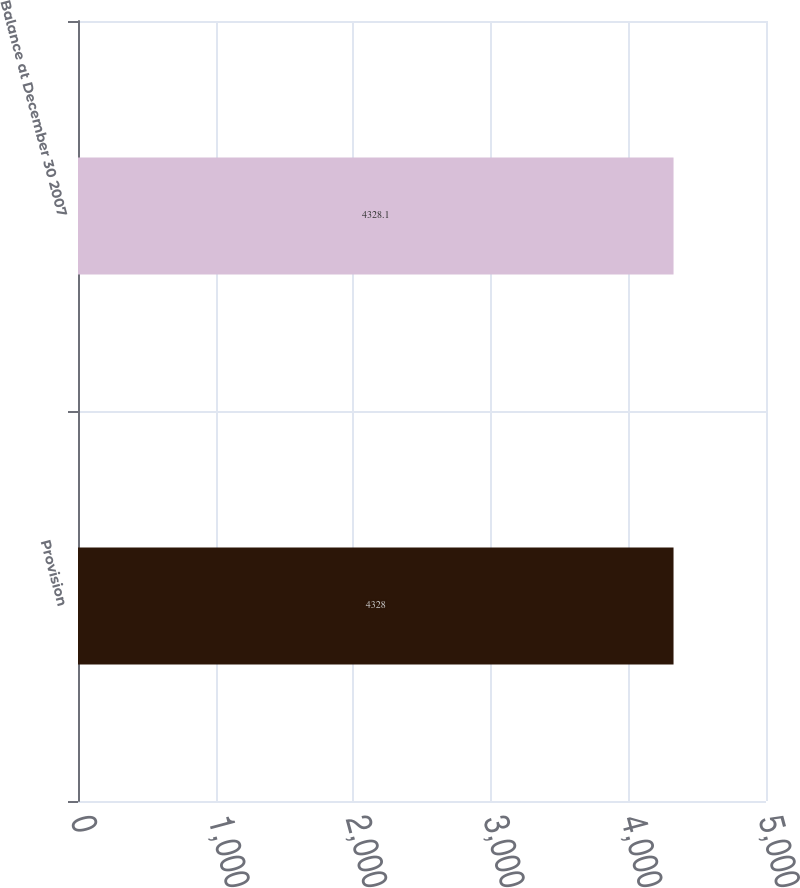Convert chart. <chart><loc_0><loc_0><loc_500><loc_500><bar_chart><fcel>Provision<fcel>Balance at December 30 2007<nl><fcel>4328<fcel>4328.1<nl></chart> 